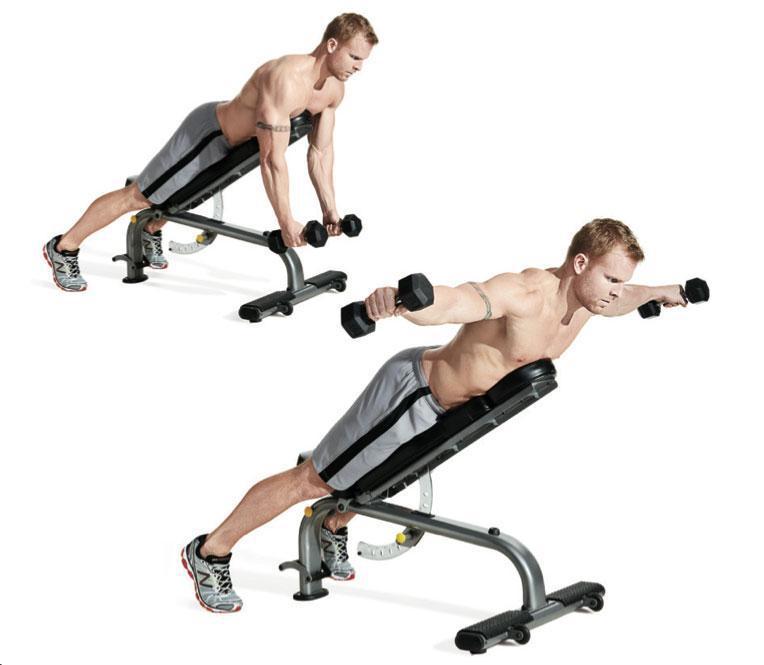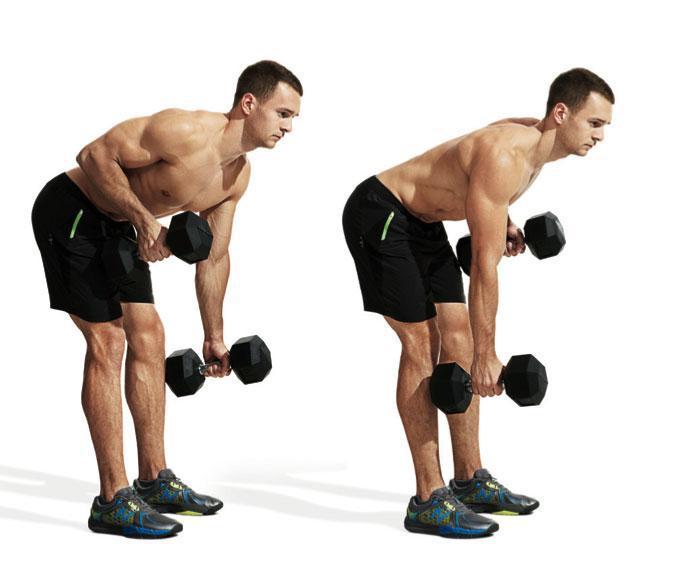The first image is the image on the left, the second image is the image on the right. Considering the images on both sides, is "There are shirtless men lifting weights" valid? Answer yes or no. Yes. The first image is the image on the left, the second image is the image on the right. Analyze the images presented: Is the assertion "There are exactly three people working out in both images." valid? Answer yes or no. No. 